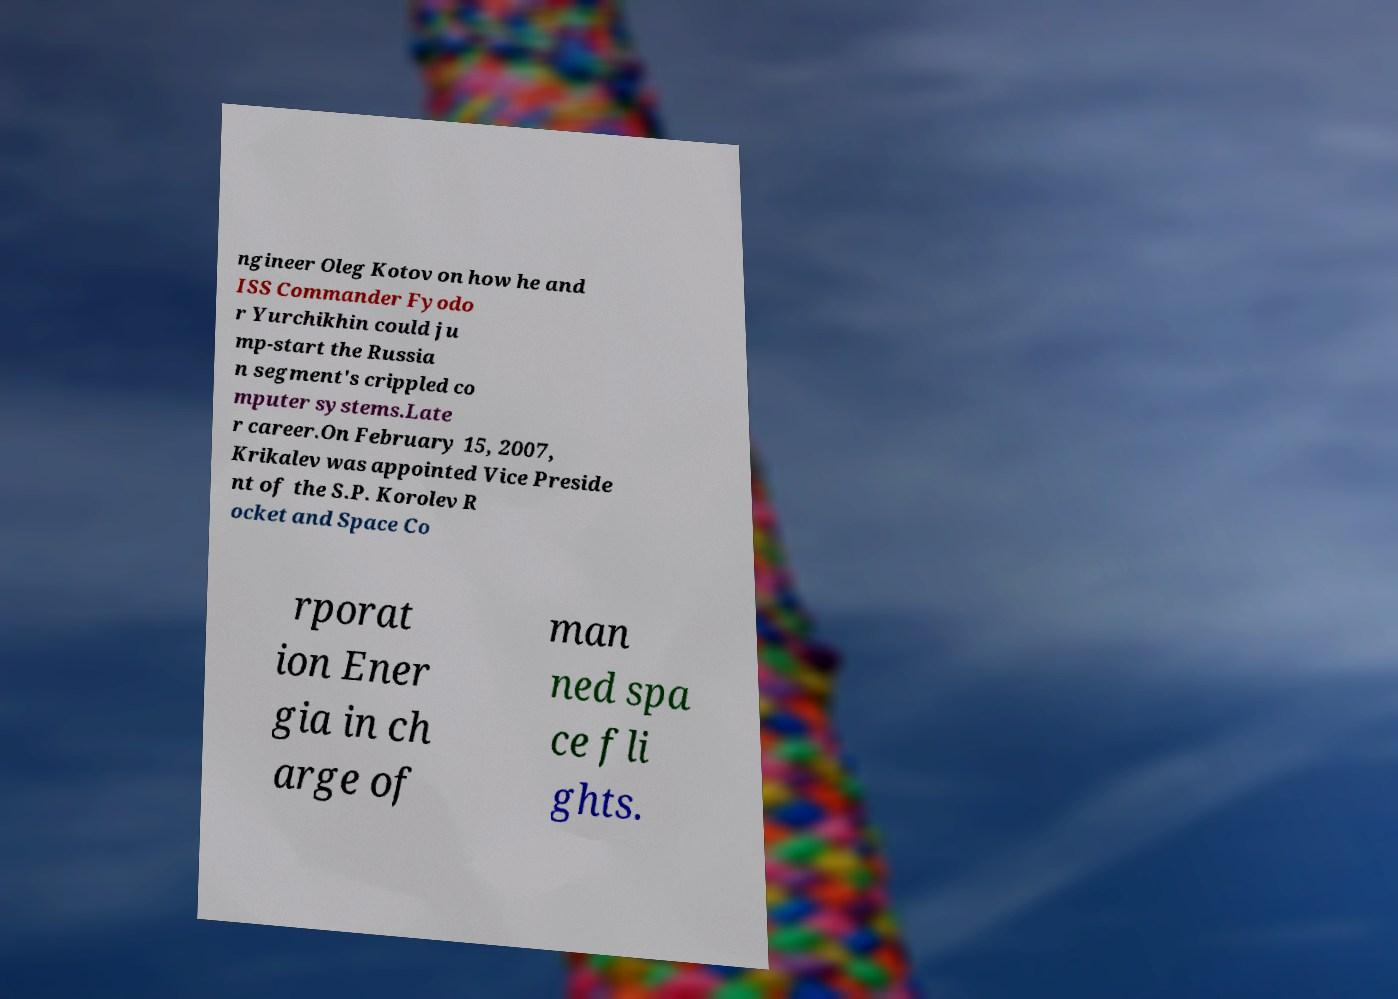What messages or text are displayed in this image? I need them in a readable, typed format. ngineer Oleg Kotov on how he and ISS Commander Fyodo r Yurchikhin could ju mp-start the Russia n segment's crippled co mputer systems.Late r career.On February 15, 2007, Krikalev was appointed Vice Preside nt of the S.P. Korolev R ocket and Space Co rporat ion Ener gia in ch arge of man ned spa ce fli ghts. 